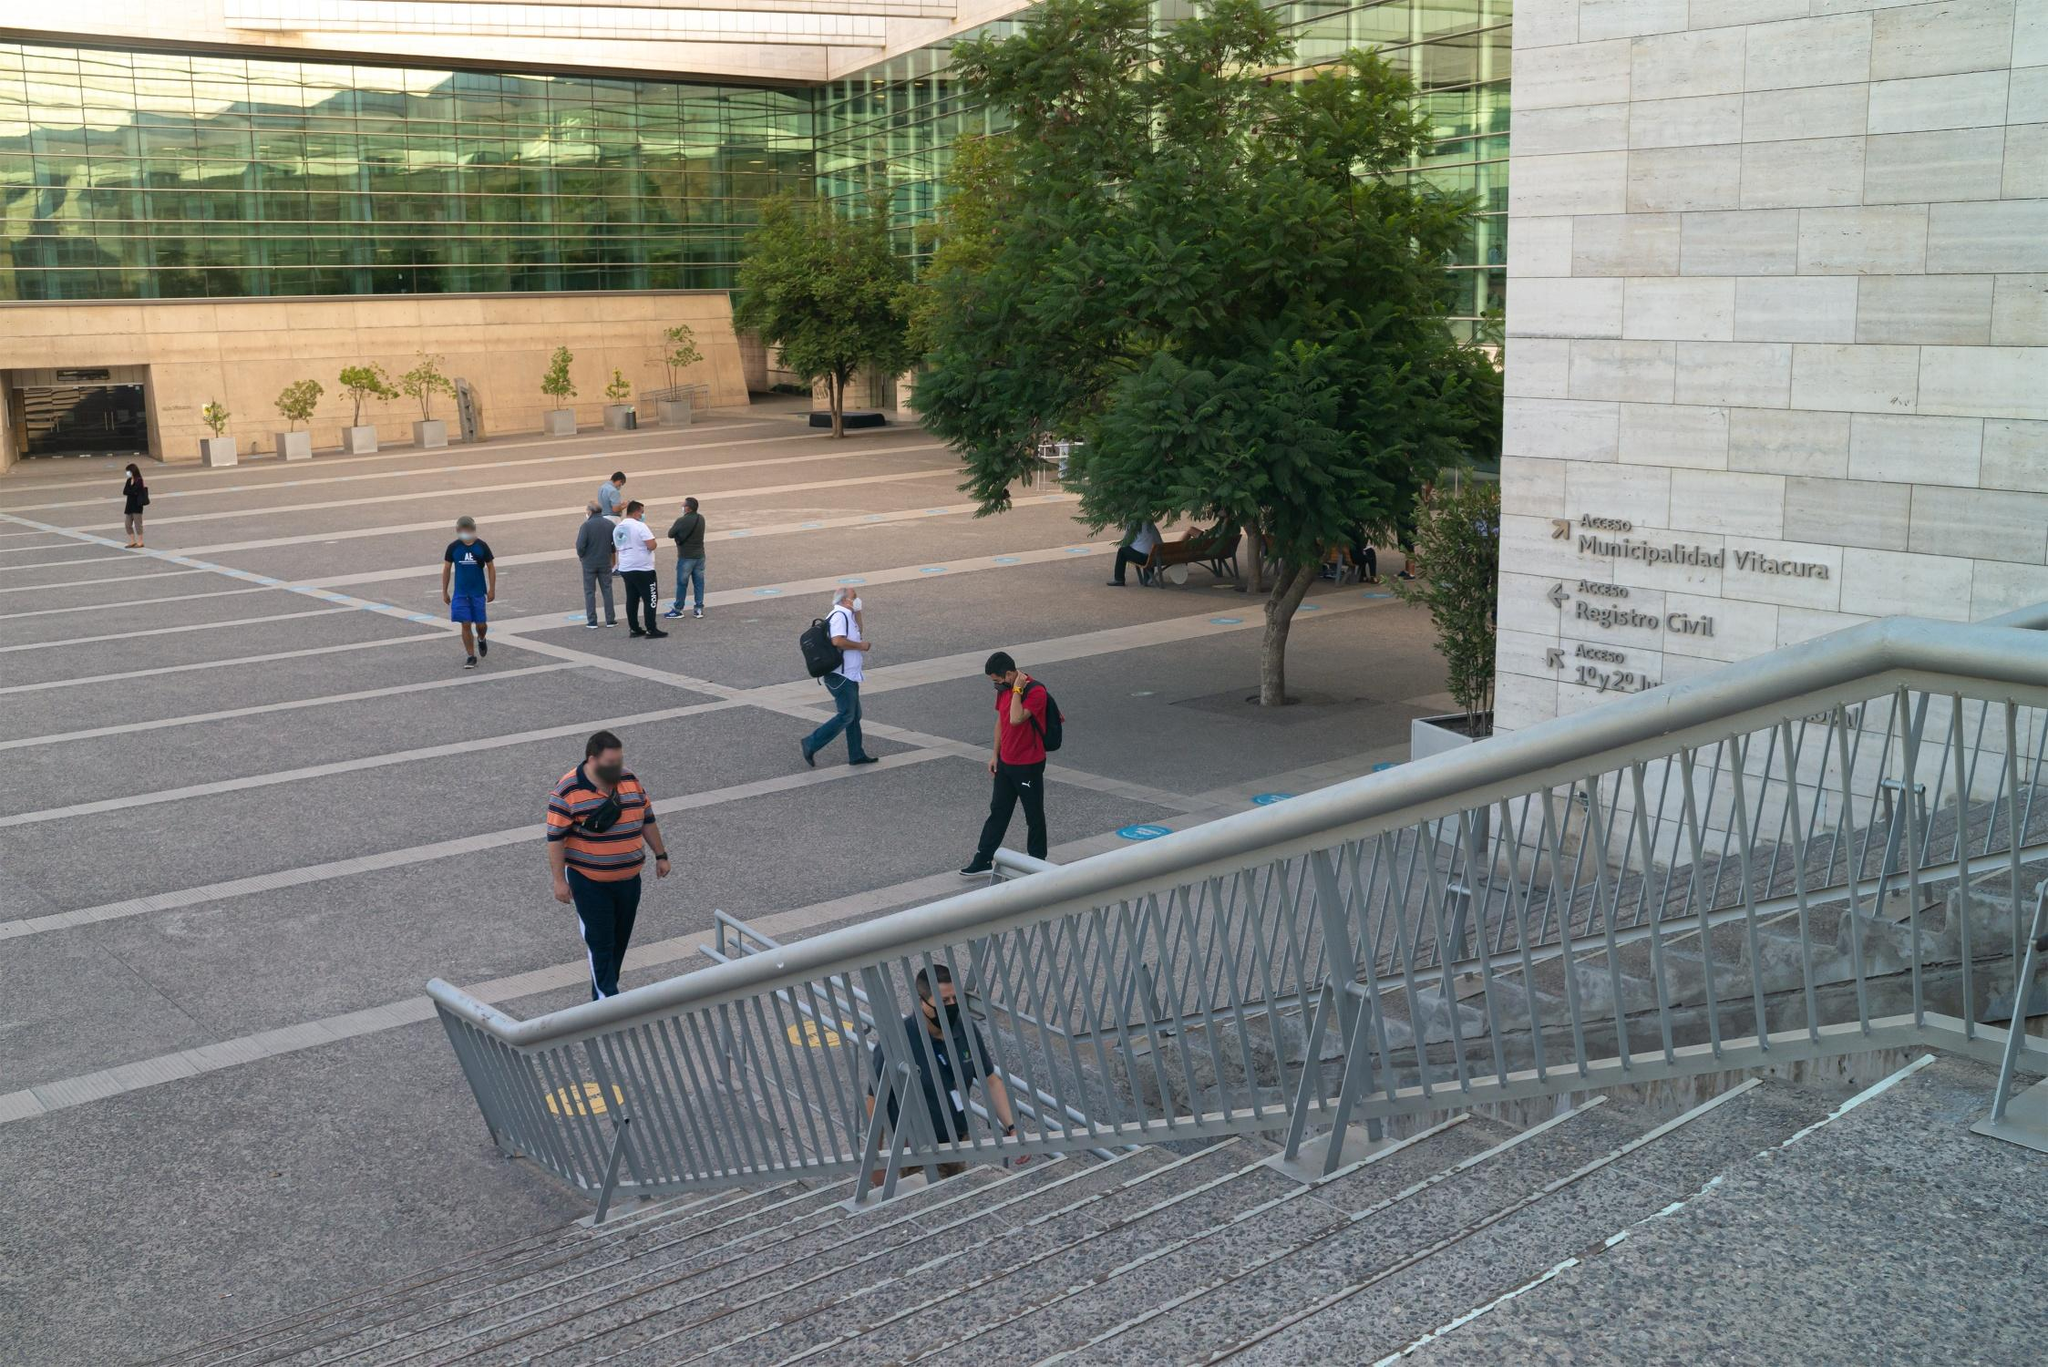How does the design of the plaza enhance the functionality of the space? The plaza's design enhances functionality through its spacious layout and the integration of both paved and green areas. The geometric pattern of the tiles helps in directing pedestrian flow and creating distinct areas for movement and rest. The inclusion of benches and a large central tree provides a comfortable resting area for visitors, making it a practical spot for relaxation and social interaction within the urban backdrop. Additionally, the orderly placement of planters and trees brings a sense of organization and aesthetic appeal to the environment. 